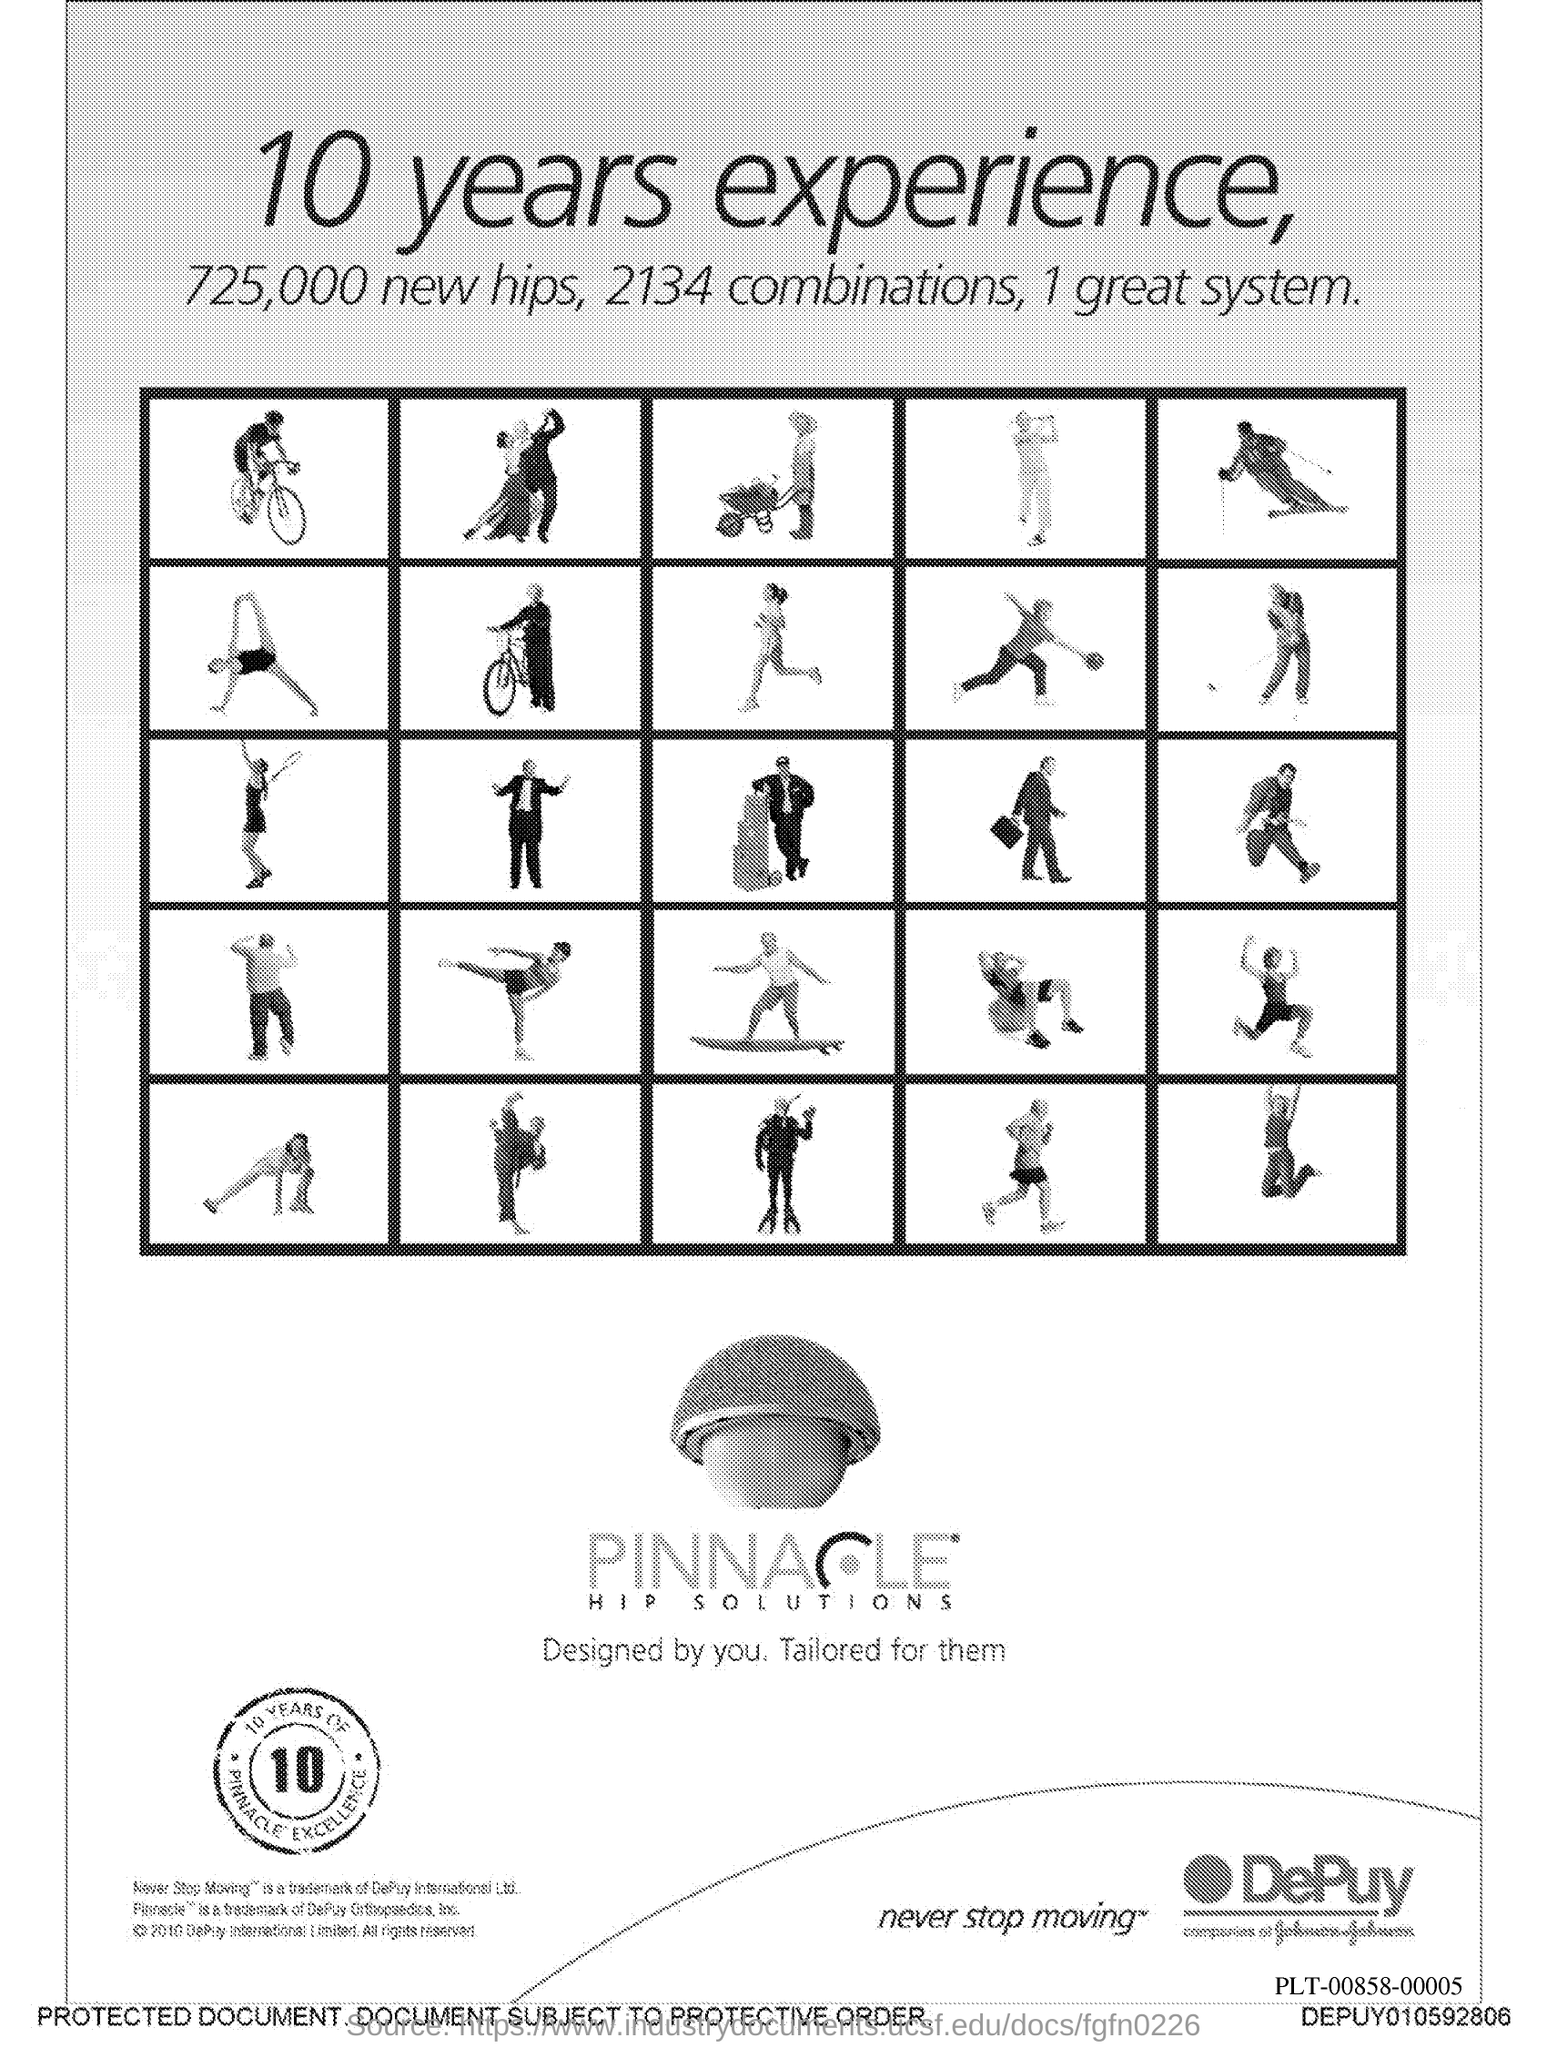Highlight a few significant elements in this photo. The total number of new hips is 725,000. 